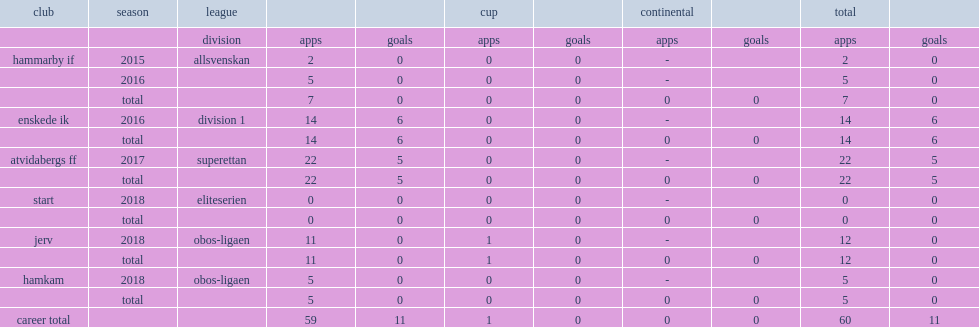In 2017, which league did isac lidberg sign with atvidabergs ff? Superettan. 